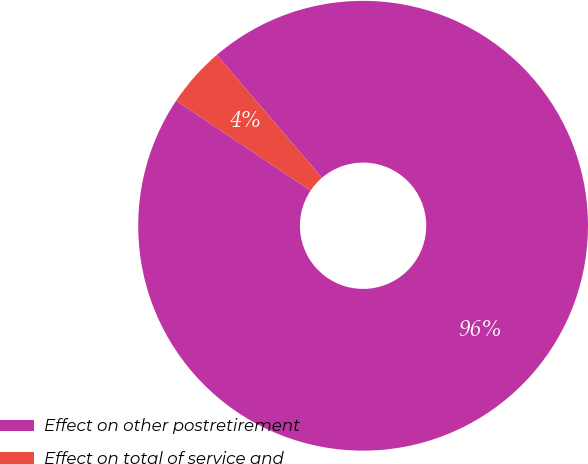Convert chart. <chart><loc_0><loc_0><loc_500><loc_500><pie_chart><fcel>Effect on other postretirement<fcel>Effect on total of service and<nl><fcel>95.65%<fcel>4.35%<nl></chart> 